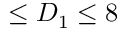Convert formula to latex. <formula><loc_0><loc_0><loc_500><loc_500>\leq D _ { 1 } \leq 8</formula> 